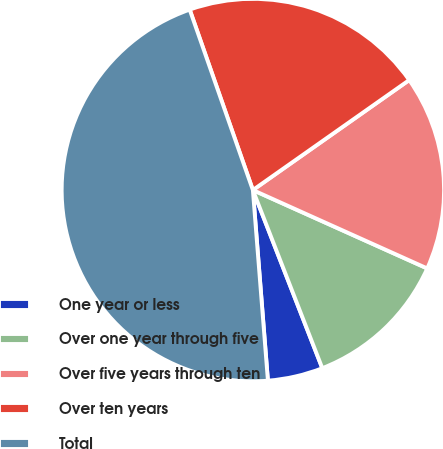Convert chart. <chart><loc_0><loc_0><loc_500><loc_500><pie_chart><fcel>One year or less<fcel>Over one year through five<fcel>Over five years through ten<fcel>Over ten years<fcel>Total<nl><fcel>4.66%<fcel>12.36%<fcel>16.48%<fcel>20.6%<fcel>45.89%<nl></chart> 